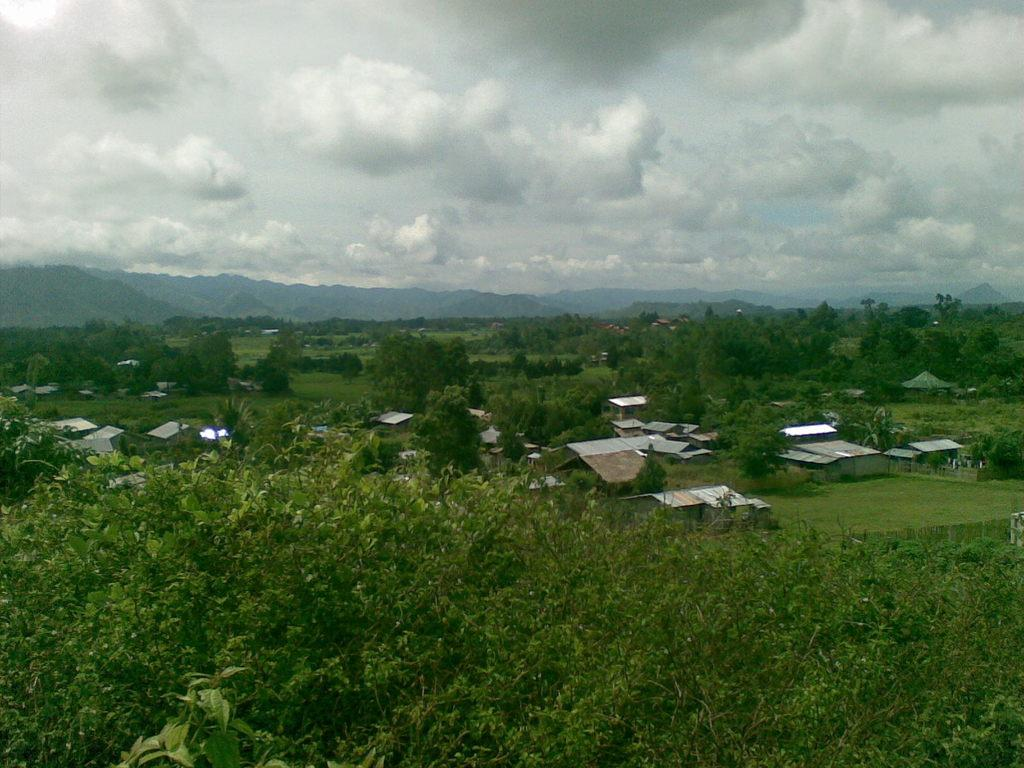What type of vegetation can be seen in the image? There are trees in the image. What type of structures are visible in the image? There are houses in the image. What type of ground cover is present in the image? There is grass in the image. What type of geographical feature can be seen in the distance? There are mountains in the image. What is visible at the top of the image? The sky is visible at the top of the image. What type of company is being advertised on the mountains in the image? There is no company being advertised on the mountains in the image; the mountains are a natural geographical feature. What type of thrill can be experienced by climbing the trees in the image? There is no indication that climbing the trees in the image is possible or encouraged, and therefore no thrill can be experienced. 